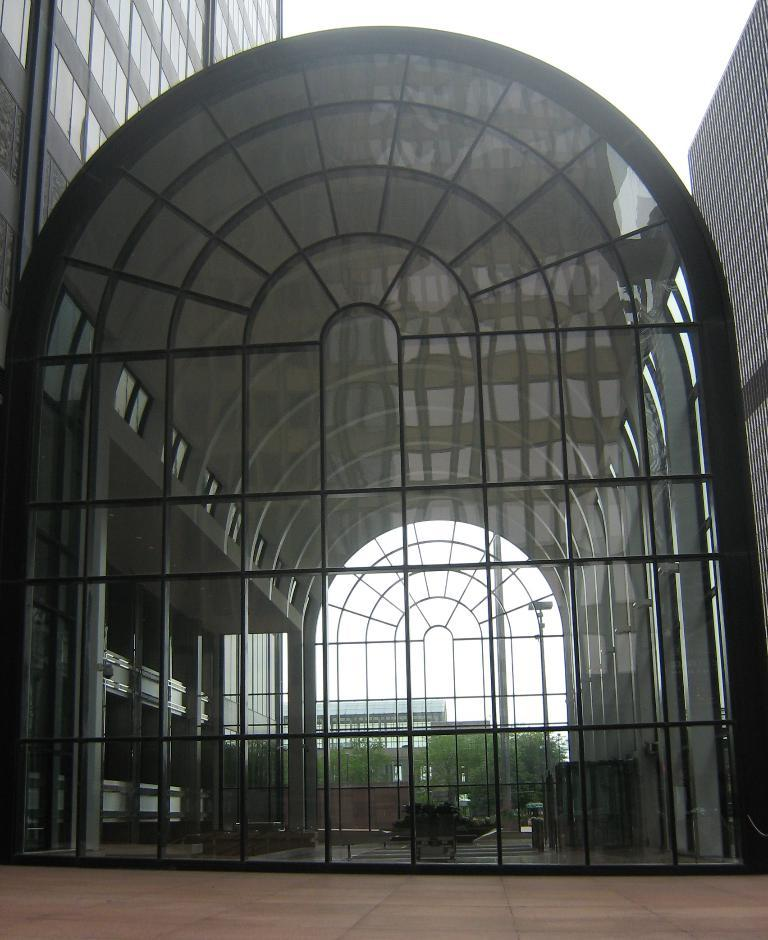What type of wall is present in the image? There is a framed glass wall in the image. What can be seen through the wall? Trees and buildings are visible in the image. What is visible in the background of the image? The sky is visible in the background of the image. What type of hat is the volcano wearing in the image? There is no volcano or hat present in the image. 